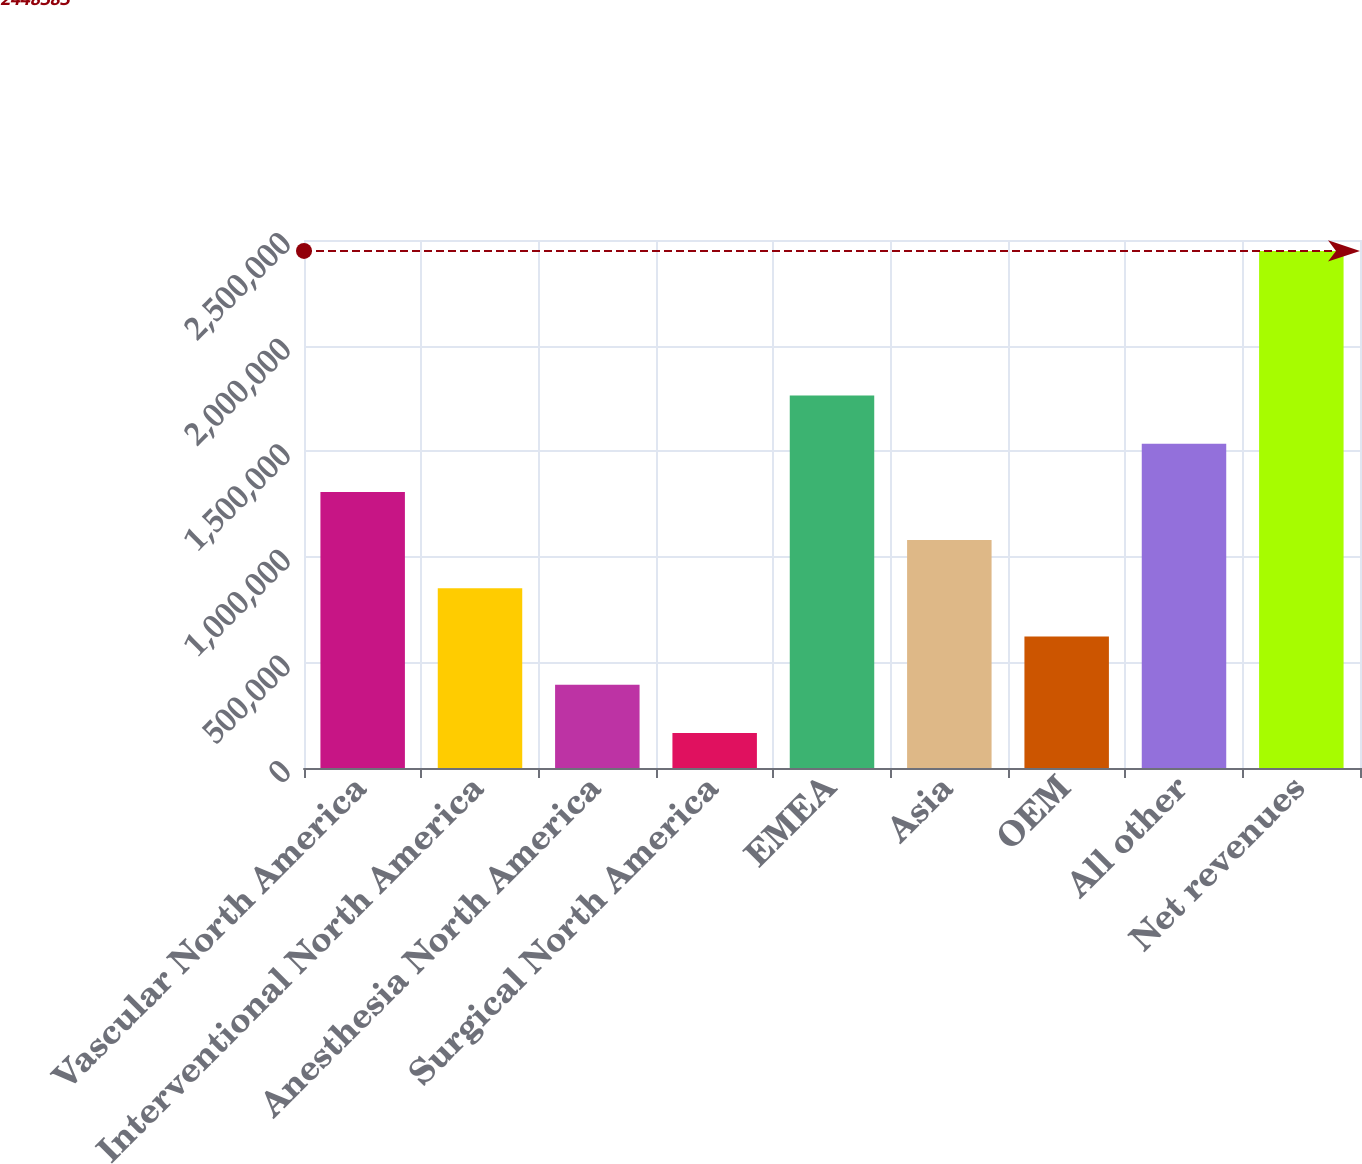Convert chart. <chart><loc_0><loc_0><loc_500><loc_500><bar_chart><fcel>Vascular North America<fcel>Interventional North America<fcel>Anesthesia North America<fcel>Surgical North America<fcel>EMEA<fcel>Asia<fcel>OEM<fcel>All other<fcel>Net revenues<nl><fcel>1.30732e+06<fcel>850902<fcel>394479<fcel>166267<fcel>1.76375e+06<fcel>1.07911e+06<fcel>622690<fcel>1.53554e+06<fcel>2.44838e+06<nl></chart> 